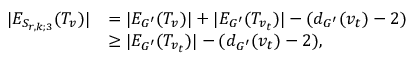Convert formula to latex. <formula><loc_0><loc_0><loc_500><loc_500>\begin{array} { r l } { | E _ { S _ { r , k ; 3 } } ( T _ { v } ) | } & { = | E _ { G ^ { \prime } } ( T _ { v } ) | + | E _ { G ^ { \prime } } ( T _ { v _ { t } } ) | - ( d _ { G ^ { \prime } } ( v _ { t } ) - 2 ) } \\ & { \geq | E _ { G ^ { \prime } } ( T _ { v _ { t } } ) | - ( d _ { G ^ { \prime } } ( v _ { t } ) - 2 ) , } \end{array}</formula> 